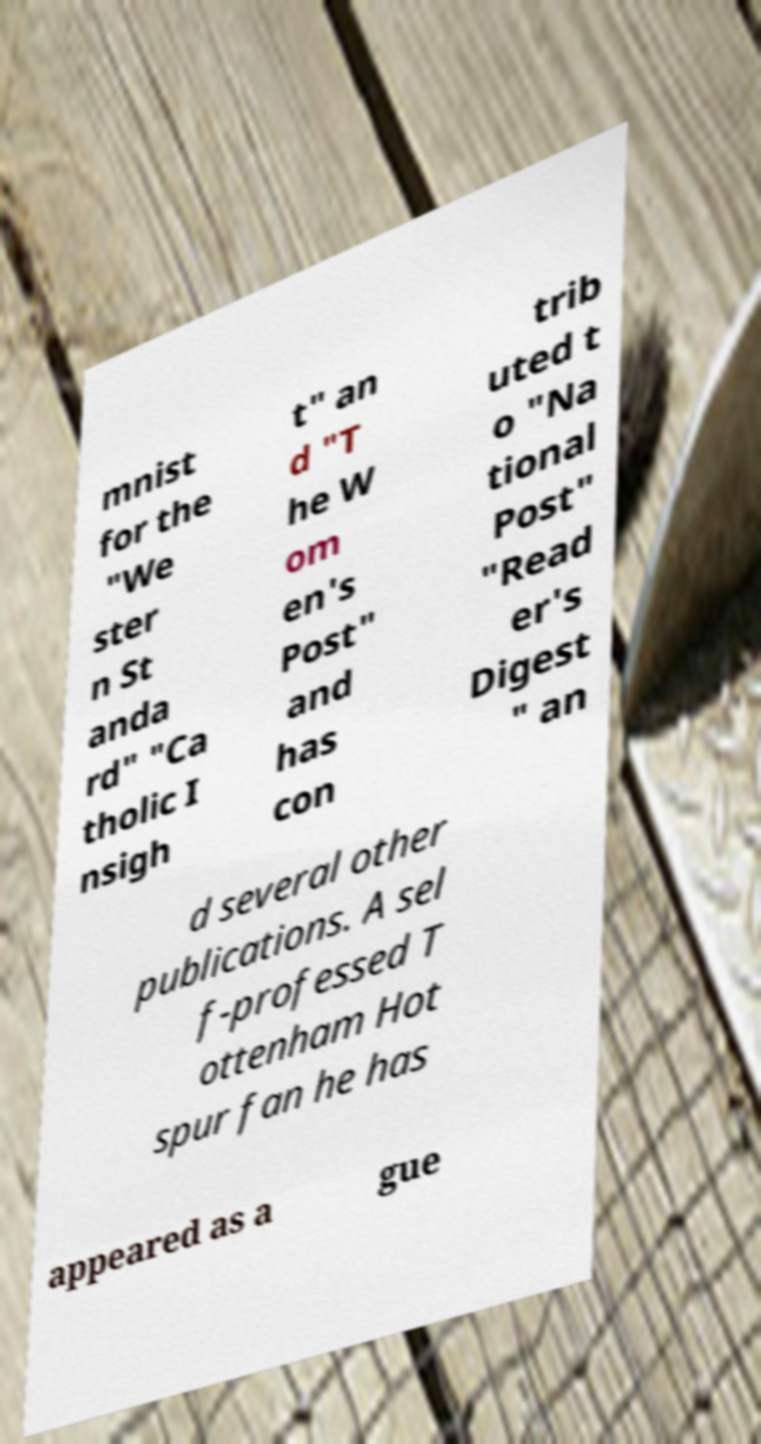There's text embedded in this image that I need extracted. Can you transcribe it verbatim? mnist for the "We ster n St anda rd" "Ca tholic I nsigh t" an d "T he W om en's Post" and has con trib uted t o "Na tional Post" "Read er's Digest " an d several other publications. A sel f-professed T ottenham Hot spur fan he has appeared as a gue 